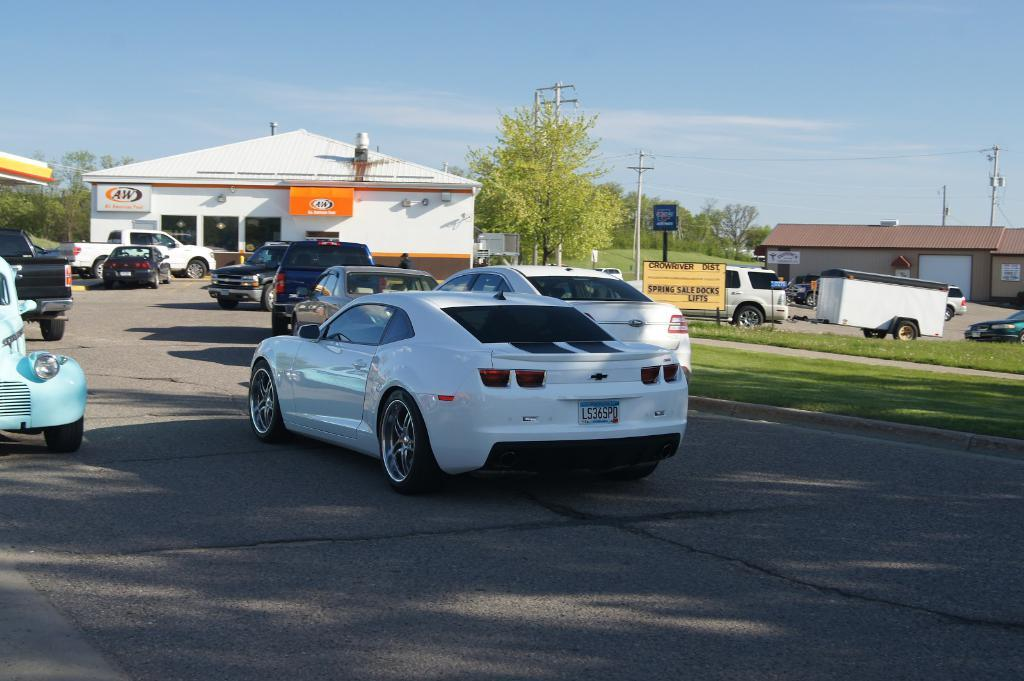What can be seen on the road in the image? There are vehicles on the road in the image. What type of vegetation is visible in the image? There is grass visible in the image. What structures are present in the image? Boards and houses are present in the image. What utility infrastructure is visible in the image? Current poles and wires are visible in the image. What type of natural elements are present in the image? Trees are present in the image. What part of the natural environment is visible in the background of the image? The sky is visible in the background of the image. Can you see a donkey jumping in the image? There is no donkey present in the image, and therefore no jumping donkey can be observed. 